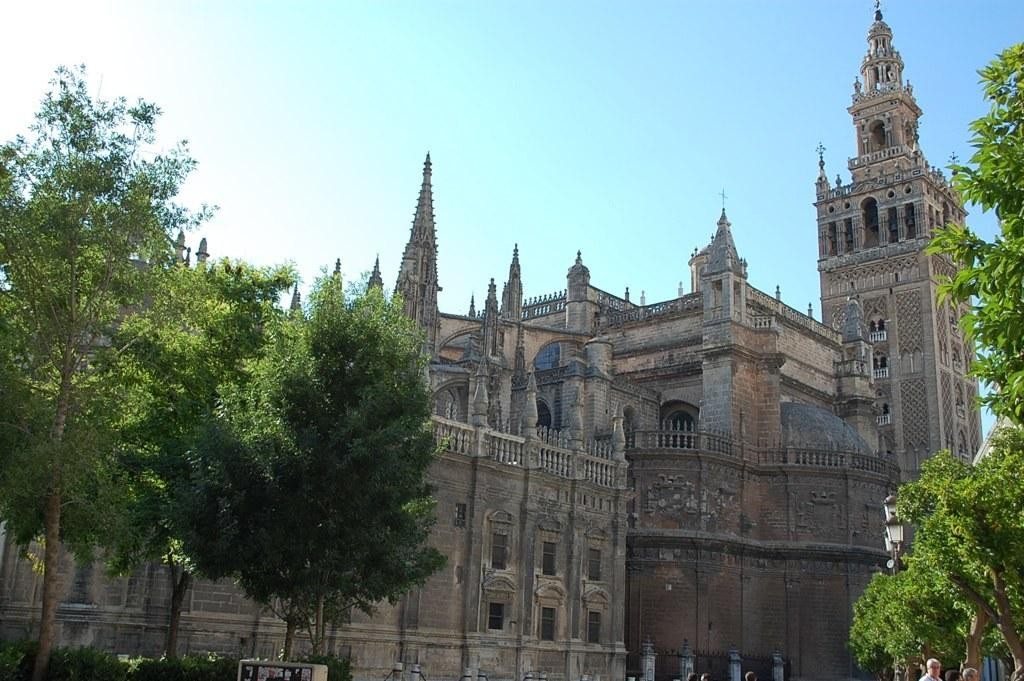What type of vegetation can be seen in the image? There are trees in the image. What is the color of the trees? The trees are green in color. Who or what else is present in the image? There are persons standing in the image. What type of structures can be seen in the image? There are buildings in the image. What colors are the buildings? The buildings have various colors, including brown, cream, and black. What is visible in the background of the image? The sky is visible in the background of the image. How many hats can be seen on the persons in the image? There is no mention of hats in the image; no one is wearing a hat. What type of seat is visible in the image? There is no seat present in the image. 